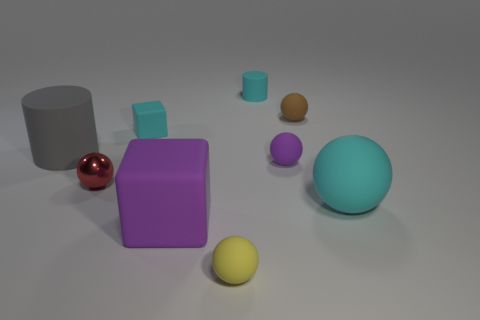Subtract all brown rubber spheres. How many spheres are left? 4 Subtract 0 yellow cylinders. How many objects are left? 9 Subtract all cylinders. How many objects are left? 7 Subtract 2 blocks. How many blocks are left? 0 Subtract all purple cubes. Subtract all green cylinders. How many cubes are left? 1 Subtract all cyan cylinders. How many purple spheres are left? 1 Subtract all big cyan rubber objects. Subtract all purple matte cubes. How many objects are left? 7 Add 1 small cubes. How many small cubes are left? 2 Add 1 tiny cyan cylinders. How many tiny cyan cylinders exist? 2 Subtract all purple blocks. How many blocks are left? 1 